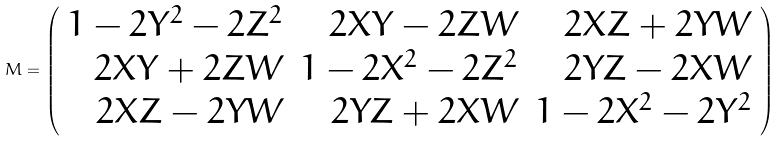Convert formula to latex. <formula><loc_0><loc_0><loc_500><loc_500>M = \left ( \begin{array} { r r r } 1 - 2 Y ^ { 2 } - 2 Z ^ { 2 } & 2 X Y - 2 Z W & 2 X Z + 2 Y W \\ 2 X Y + 2 Z W & 1 - 2 X ^ { 2 } - 2 Z ^ { 2 } & 2 Y Z - 2 X W \\ 2 X Z - 2 Y W & 2 Y Z + 2 X W & 1 - 2 X ^ { 2 } - 2 Y ^ { 2 } \end{array} \right )</formula> 